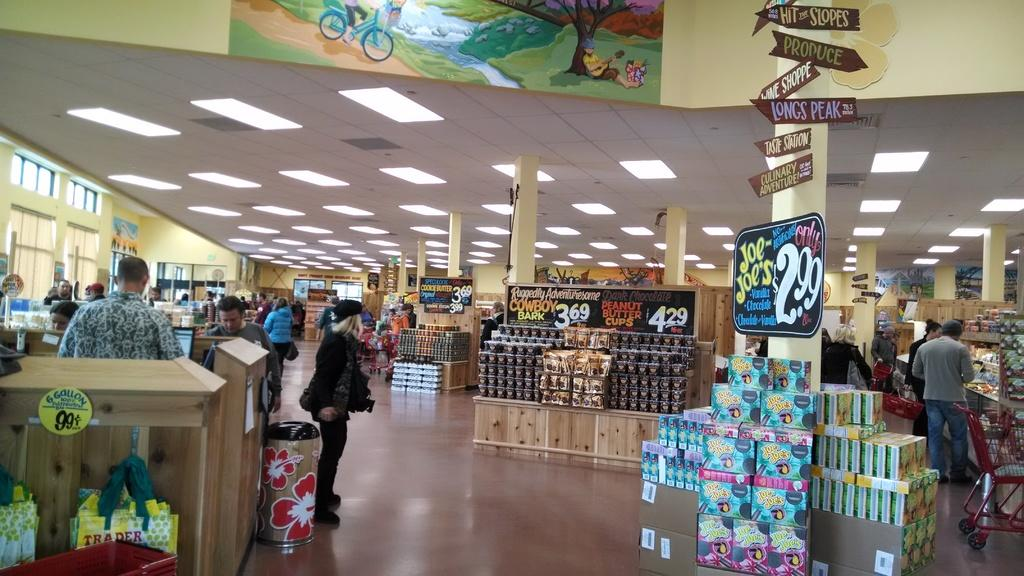Provide a one-sentence caption for the provided image. Advertisement for Joe Joe's in a store for 2.99. 